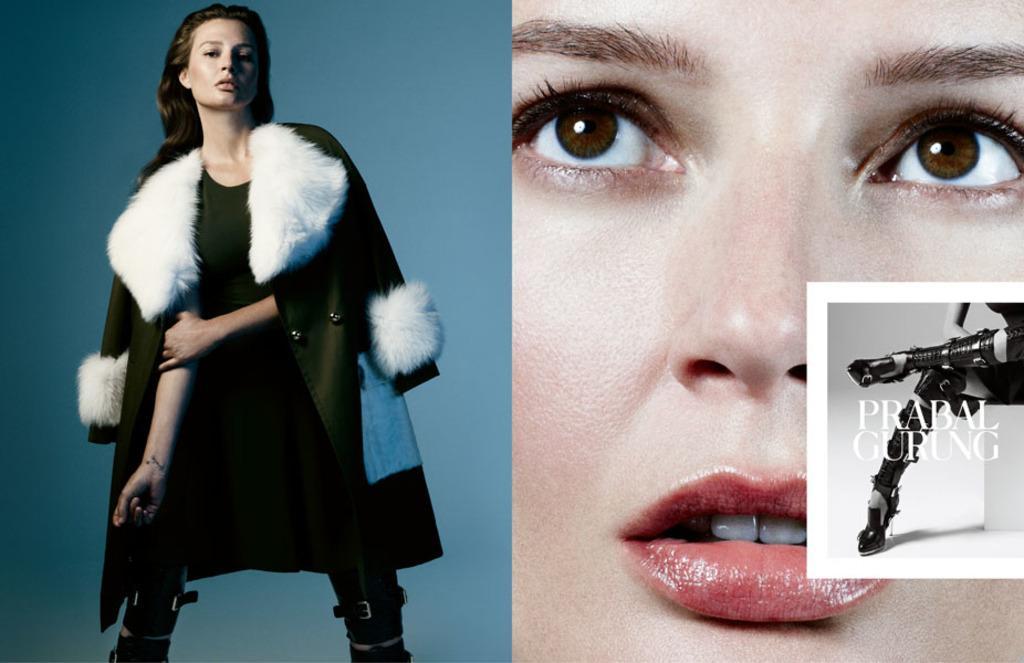Please provide a concise description of this image. In this image, on the right side, we can see face of a person, we can also see legs and hand of a person. On the left side, we can see a woman wearing a black color dress. In the background, we can see blue color. 